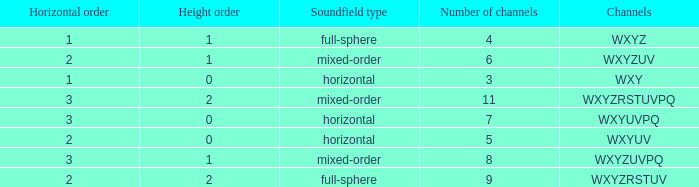If the channels is wxyzuv, what is the number of channels? 6.0. 